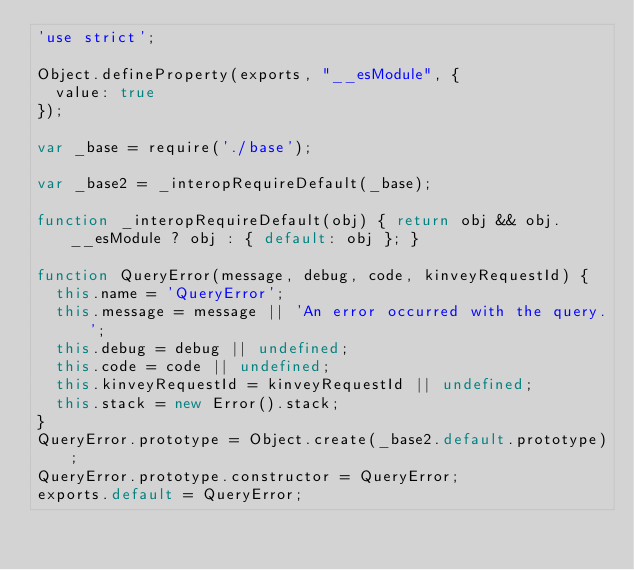Convert code to text. <code><loc_0><loc_0><loc_500><loc_500><_JavaScript_>'use strict';

Object.defineProperty(exports, "__esModule", {
  value: true
});

var _base = require('./base');

var _base2 = _interopRequireDefault(_base);

function _interopRequireDefault(obj) { return obj && obj.__esModule ? obj : { default: obj }; }

function QueryError(message, debug, code, kinveyRequestId) {
  this.name = 'QueryError';
  this.message = message || 'An error occurred with the query.';
  this.debug = debug || undefined;
  this.code = code || undefined;
  this.kinveyRequestId = kinveyRequestId || undefined;
  this.stack = new Error().stack;
}
QueryError.prototype = Object.create(_base2.default.prototype);
QueryError.prototype.constructor = QueryError;
exports.default = QueryError;</code> 